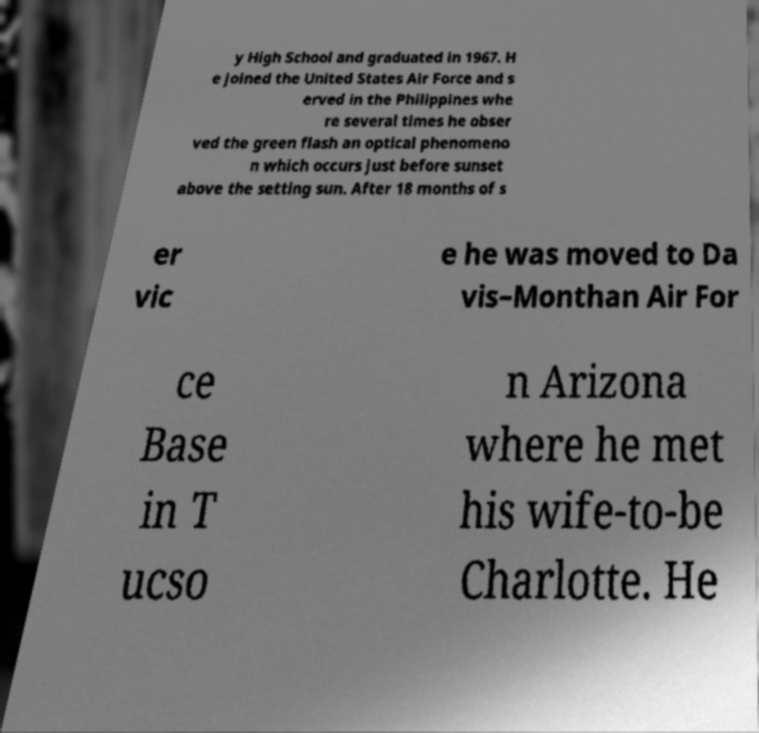Can you accurately transcribe the text from the provided image for me? y High School and graduated in 1967. H e joined the United States Air Force and s erved in the Philippines whe re several times he obser ved the green flash an optical phenomeno n which occurs just before sunset above the setting sun. After 18 months of s er vic e he was moved to Da vis–Monthan Air For ce Base in T ucso n Arizona where he met his wife-to-be Charlotte. He 